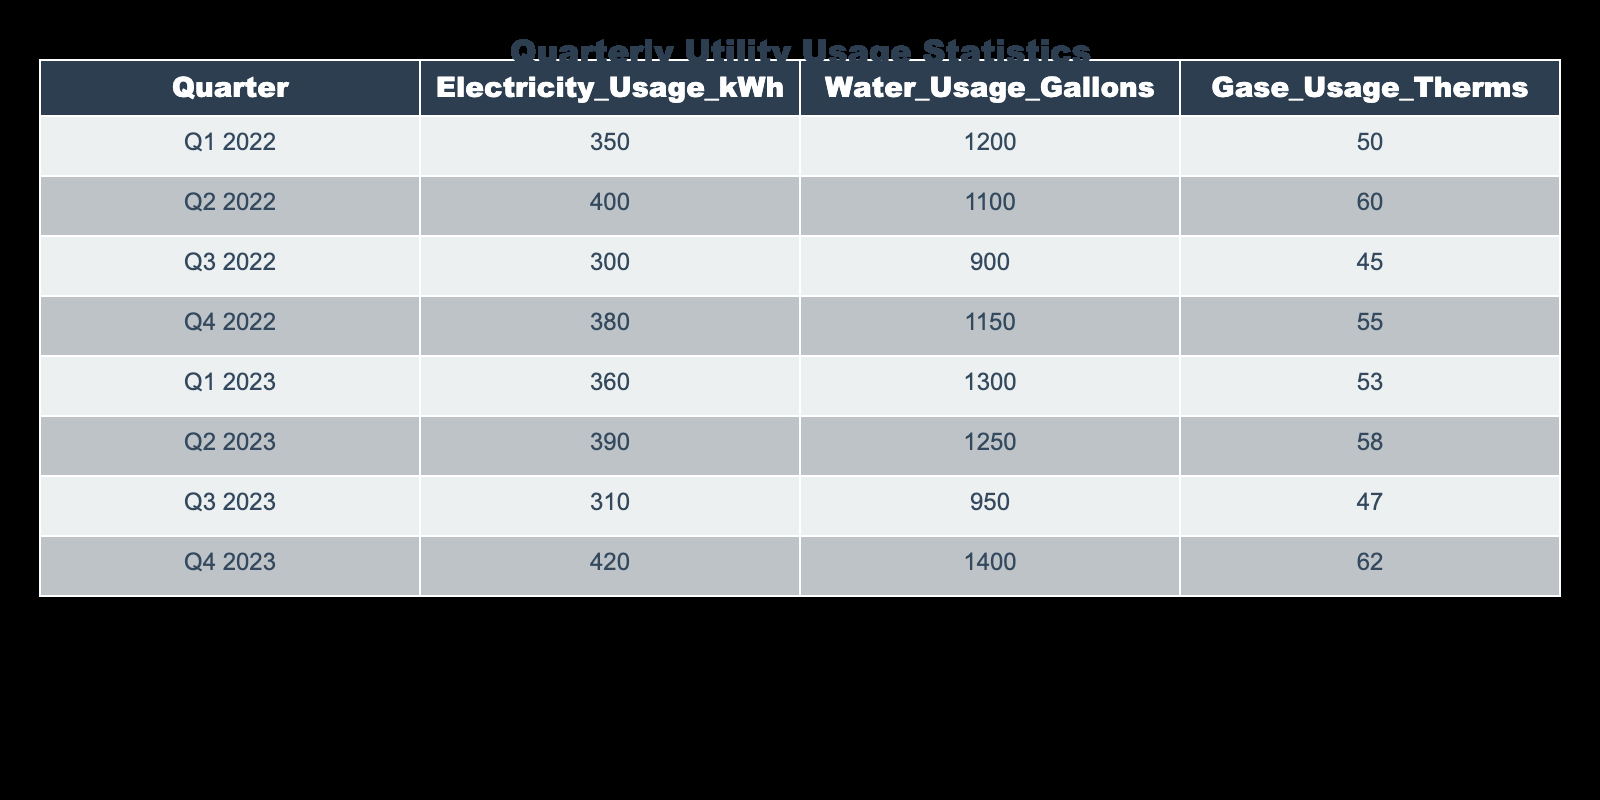What was the total electricity usage in 2022? To find the total electricity usage in 2022, we sum the values of electricity usage for Q1, Q2, Q3, and Q4 of 2022: 350 + 400 + 300 + 380 = 1430 kWh.
Answer: 1430 kWh Which quarter had the highest water usage? Looking at the table, Q4 2023 shows the highest water usage at 1400 gallons.
Answer: Q4 2023 What is the average gas usage across all quarters? To find the average gas usage, sum the gas usage values (50 + 60 + 45 + 55 + 53 + 58 + 47 + 62 = 426) and divide by 8 (the number of quarters): 426 / 8 = 53.25 therms.
Answer: 53.25 therms Did the electricity usage increase from Q3 2022 to Q4 2022? Comparing the values, Q3 2022 has 300 kWh and Q4 2022 has 380 kWh. Since 380 is greater than 300, the usage did increase.
Answer: Yes What is the difference in water usage between Q1 2022 and Q1 2023? The water usage for Q1 2022 is 1200 gallons, and for Q1 2023 it is 1300 gallons. The difference is calculated as 1300 - 1200 = 100 gallons.
Answer: 100 gallons Which quarter had the lowest gas usage? Looking at the gas usage values, Q3 2022 shows the lowest usage at 45 therms.
Answer: Q3 2022 What was the total water usage for the first half of 2023? To find the total water usage in the first half of 2023, we add the water usage from Q1 2023 (1300 gallons) and Q2 2023 (1250 gallons): 1300 + 1250 = 2550 gallons.
Answer: 2550 gallons Was the total electricity usage for 2023 higher than for 2022? For 2022, total electricity usage is 1430 kWh and for 2023 the total is (360 + 390 + 310 + 420 = 1480 kWh). Since 1480 is greater than 1430, the total usage for 2023 was higher.
Answer: Yes 